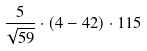Convert formula to latex. <formula><loc_0><loc_0><loc_500><loc_500>\frac { 5 } { \sqrt { 5 9 } } \cdot ( 4 - 4 2 ) \cdot 1 1 5</formula> 